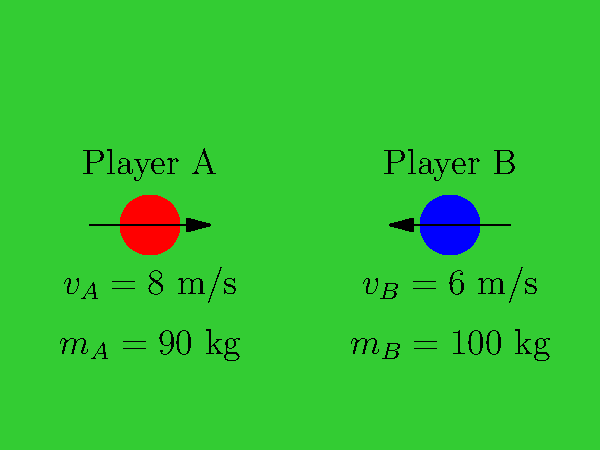Two football players, A and B, are running directly towards each other on the field. Player A has a mass of 90 kg and is moving at 8 m/s, while Player B has a mass of 100 kg and is moving at 6 m/s in the opposite direction. If they collide and stick together, what will be their velocity immediately after the collision? To solve this problem, we'll use the principle of conservation of momentum. The total momentum before the collision must equal the total momentum after the collision.

Step 1: Calculate the initial momentum of each player.
Player A: $p_A = m_A v_A = 90 \text{ kg} \times 8 \text{ m/s} = 720 \text{ kg}\cdot\text{m/s}$
Player B: $p_B = m_B v_B = 100 \text{ kg} \times (-6 \text{ m/s}) = -600 \text{ kg}\cdot\text{m/s}$
(Note: We use a negative velocity for Player B since they're moving in the opposite direction)

Step 2: Calculate the total initial momentum.
$p_{total} = p_A + p_B = 720 \text{ kg}\cdot\text{m/s} + (-600 \text{ kg}\cdot\text{m/s}) = 120 \text{ kg}\cdot\text{m/s}$

Step 3: Use conservation of momentum to find the final velocity.
$(m_A + m_B)v_f = p_{total}$
$v_f = \frac{p_{total}}{m_A + m_B} = \frac{120 \text{ kg}\cdot\text{m/s}}{90 \text{ kg} + 100 \text{ kg}} = \frac{120}{190} \text{ m/s} \approx 0.632 \text{ m/s}$

Therefore, immediately after the collision, both players will move together in the direction Player A was originally moving, at a speed of approximately 0.632 m/s.
Answer: 0.632 m/s in Player A's original direction 